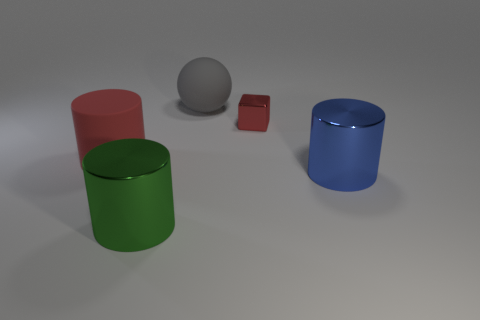Subtract 1 cylinders. How many cylinders are left? 2 Subtract all big metal cylinders. How many cylinders are left? 1 Add 2 big gray balls. How many objects exist? 7 Subtract all spheres. How many objects are left? 4 Subtract all large gray spheres. Subtract all big red matte things. How many objects are left? 3 Add 1 rubber things. How many rubber things are left? 3 Add 5 large cyan things. How many large cyan things exist? 5 Subtract 0 green blocks. How many objects are left? 5 